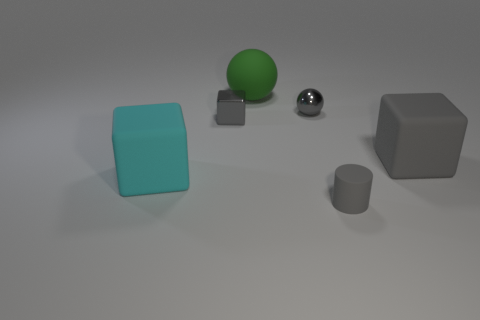Add 2 cyan cubes. How many objects exist? 8 Subtract all cylinders. How many objects are left? 5 Add 5 matte cylinders. How many matte cylinders are left? 6 Add 2 metal blocks. How many metal blocks exist? 3 Subtract 0 blue cylinders. How many objects are left? 6 Subtract all large yellow shiny objects. Subtract all big rubber cubes. How many objects are left? 4 